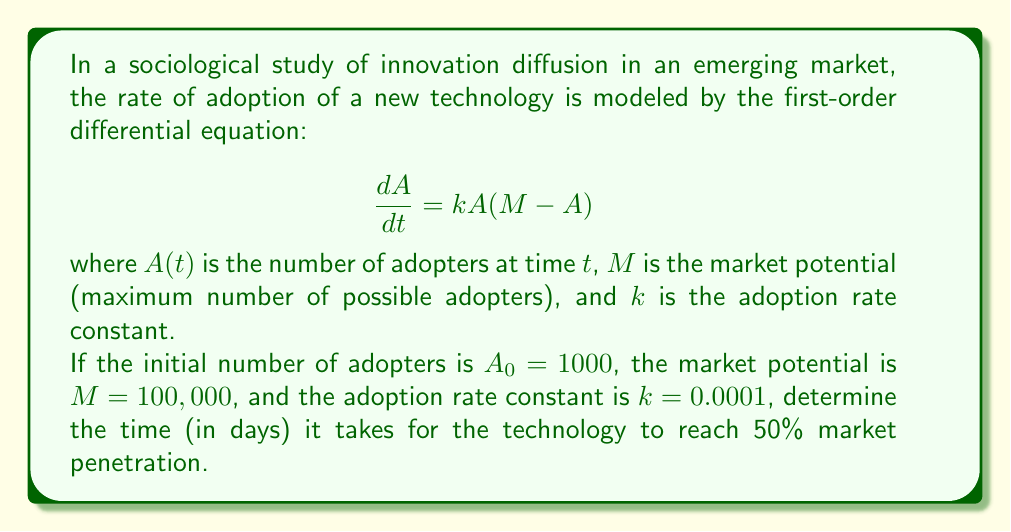Provide a solution to this math problem. To solve this problem, we need to follow these steps:

1) First, we need to solve the differential equation. This is a logistic growth model, and its solution is:

   $$A(t) = \frac{M}{1 + (\frac{M}{A_0} - 1)e^{-kMt}}$$

2) We're looking for the time when $A(t) = 0.5M = 50,000$. Let's call this time $t_{50\%}$. Substituting these values:

   $$50,000 = \frac{100,000}{1 + (\frac{100,000}{1000} - 1)e^{-0.0001 \cdot 100,000 \cdot t_{50\%}}}$$

3) Simplify:

   $$0.5 = \frac{1}{1 + 99e^{-10t_{50\%}}}$$

4) Solve for $e^{-10t_{50\%}}$:

   $$1 = \frac{2}{1 + 99e^{-10t_{50\%}}}$$
   $$1 + 99e^{-10t_{50\%}} = 2$$
   $$99e^{-10t_{50\%}} = 1$$
   $$e^{-10t_{50\%}} = \frac{1}{99}$$

5) Take the natural log of both sides:

   $$-10t_{50\%} = \ln(\frac{1}{99}) = -\ln(99)$$

6) Solve for $t_{50\%}$:

   $$t_{50\%} = \frac{\ln(99)}{10} \approx 0.4605$$

7) Convert to days (multiply by 365):

   $$t_{50\%} \approx 0.4605 \cdot 365 \approx 168.1 \text{ days}$$
Answer: It takes approximately 168 days for the technology to reach 50% market penetration. 